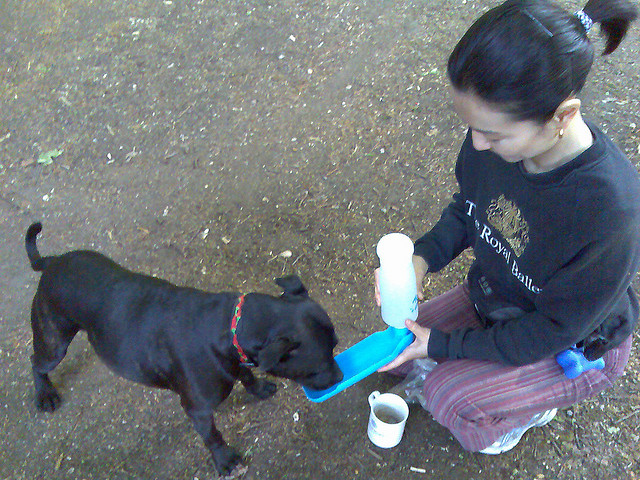Please transcribe the text information in this image. T.R Royal Balle 